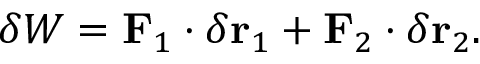<formula> <loc_0><loc_0><loc_500><loc_500>\delta W = F _ { 1 } \cdot \delta r _ { 1 } + F _ { 2 } \cdot \delta r _ { 2 } .</formula> 